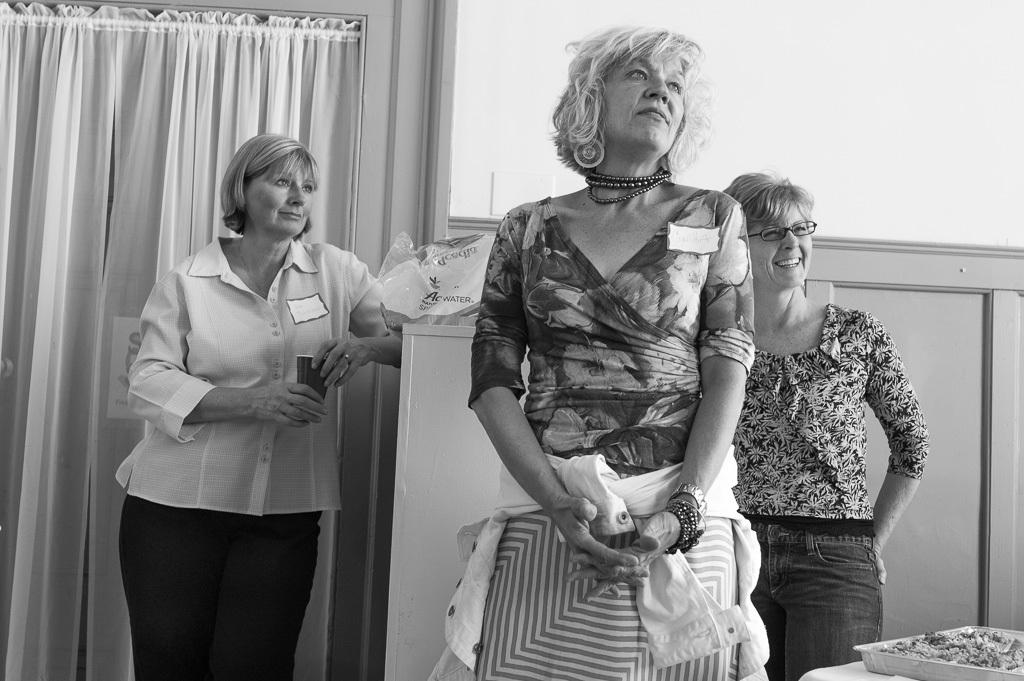How many women are present in the image? There are three women in the image. What type of furniture can be seen in the image? There are cupboards in the image. What is the background of the image? There is a wall in the image. What architectural feature is present in the image? There is a window with curtains in the image. What object is located at the bottom of the image? There is a tray at the bottom of the image. What color are the women's toes in the image? There is no information about the women's toes in the image, so we cannot determine their color. 